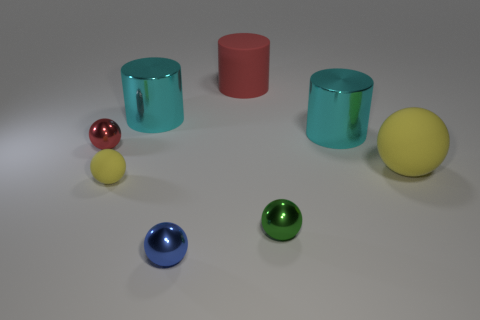Subtract all red spheres. How many spheres are left? 4 Subtract 2 balls. How many balls are left? 3 Subtract all small matte spheres. How many spheres are left? 4 Subtract all cyan balls. Subtract all red cubes. How many balls are left? 5 Add 2 yellow matte balls. How many objects exist? 10 Subtract all cylinders. How many objects are left? 5 Add 2 red cylinders. How many red cylinders are left? 3 Add 4 large brown matte cylinders. How many large brown matte cylinders exist? 4 Subtract 0 purple cylinders. How many objects are left? 8 Subtract all cyan things. Subtract all large yellow rubber spheres. How many objects are left? 5 